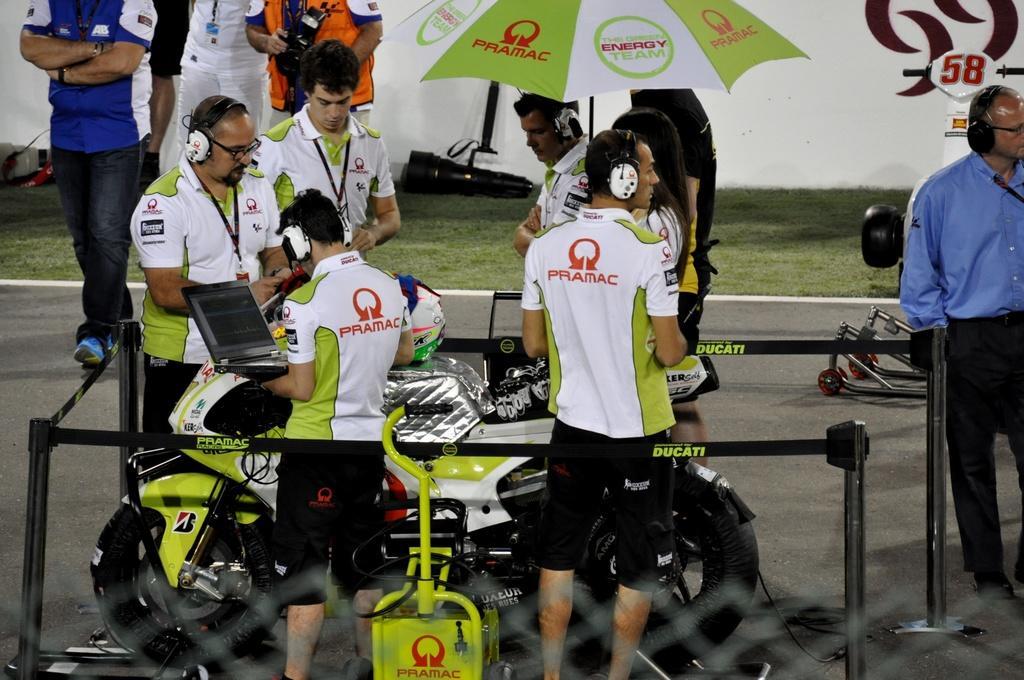Could you give a brief overview of what you see in this image? In this image I can see few people are wearing t-shirts, shorts, headsets, holding laptops in their hands and standing around a bike. On the right side I can see a man wearing blue color shirt, standing and looking at the right side. In the background, I can see few people are walking on the road and one one person is holding an umbrella. On the other side of the road I can see the grass in green color. 